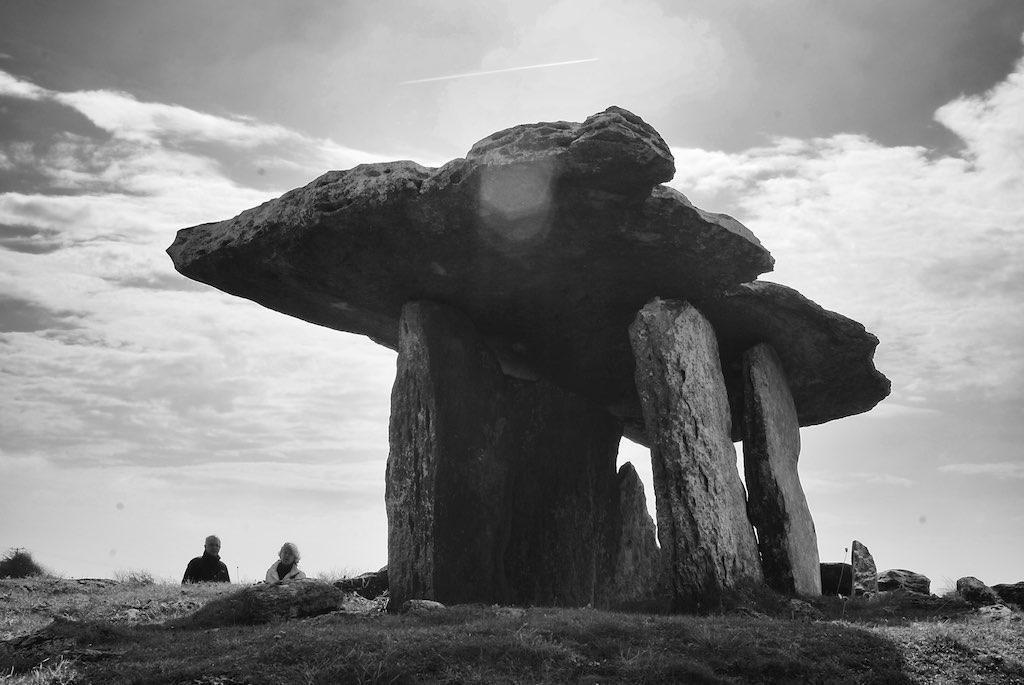Please provide a concise description of this image. In this image I can see in the middle there is the structure with the stones. On the left side two persons are there, at the top it is the sky, this image is in black and white color. 